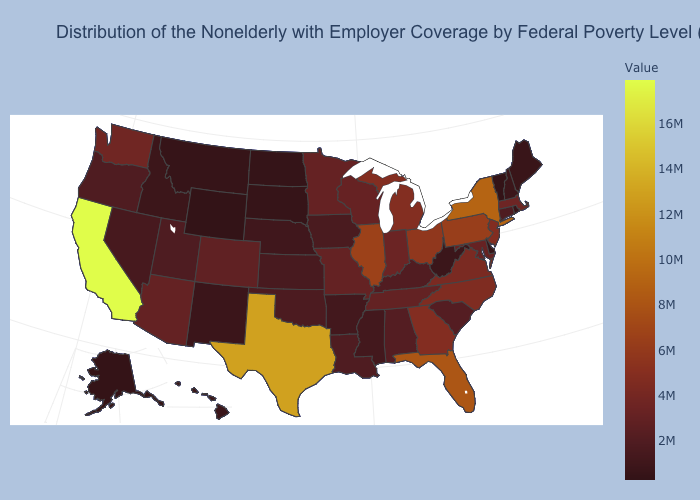Does California have the highest value in the USA?
Keep it brief. Yes. Does Georgia have the lowest value in the South?
Keep it brief. No. Does Alaska have a higher value than Massachusetts?
Concise answer only. No. Among the states that border Kansas , does Missouri have the highest value?
Write a very short answer. Yes. 